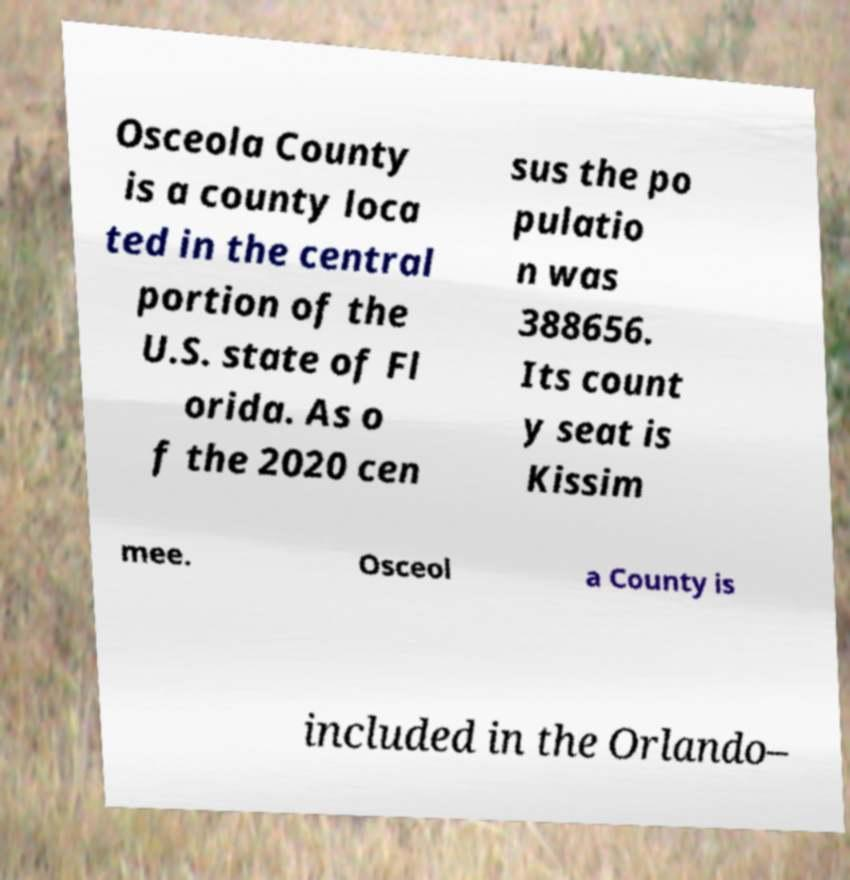Please read and relay the text visible in this image. What does it say? Osceola County is a county loca ted in the central portion of the U.S. state of Fl orida. As o f the 2020 cen sus the po pulatio n was 388656. Its count y seat is Kissim mee. Osceol a County is included in the Orlando– 